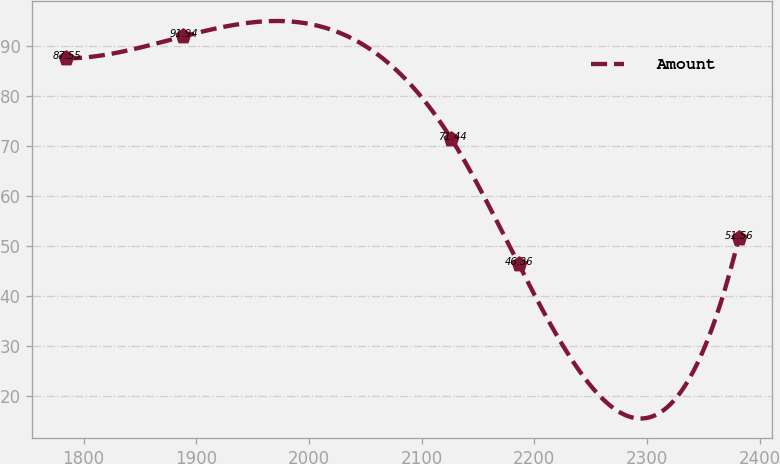<chart> <loc_0><loc_0><loc_500><loc_500><line_chart><ecel><fcel>Amount<nl><fcel>1784.48<fcel>87.55<nl><fcel>1888.21<fcel>91.94<nl><fcel>2126.44<fcel>71.44<nl><fcel>2186.14<fcel>46.36<nl><fcel>2381.47<fcel>51.56<nl></chart> 